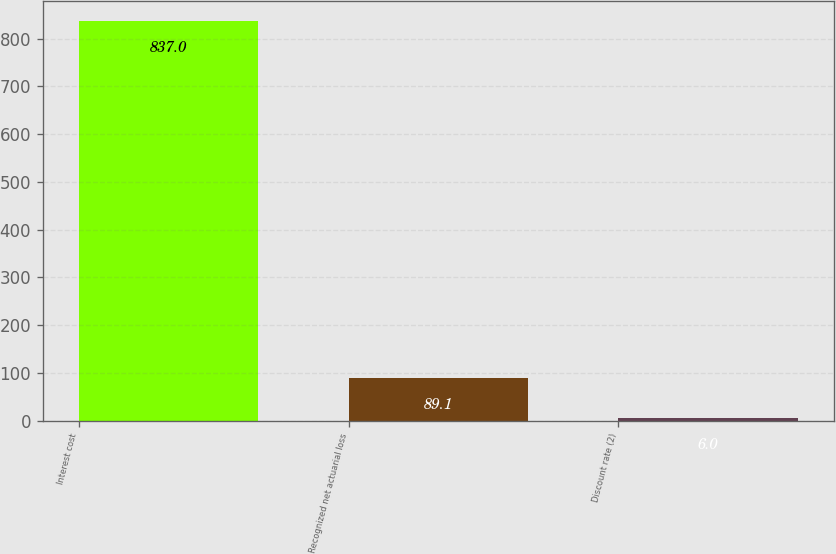Convert chart. <chart><loc_0><loc_0><loc_500><loc_500><bar_chart><fcel>Interest cost<fcel>Recognized net actuarial loss<fcel>Discount rate (2)<nl><fcel>837<fcel>89.1<fcel>6<nl></chart> 